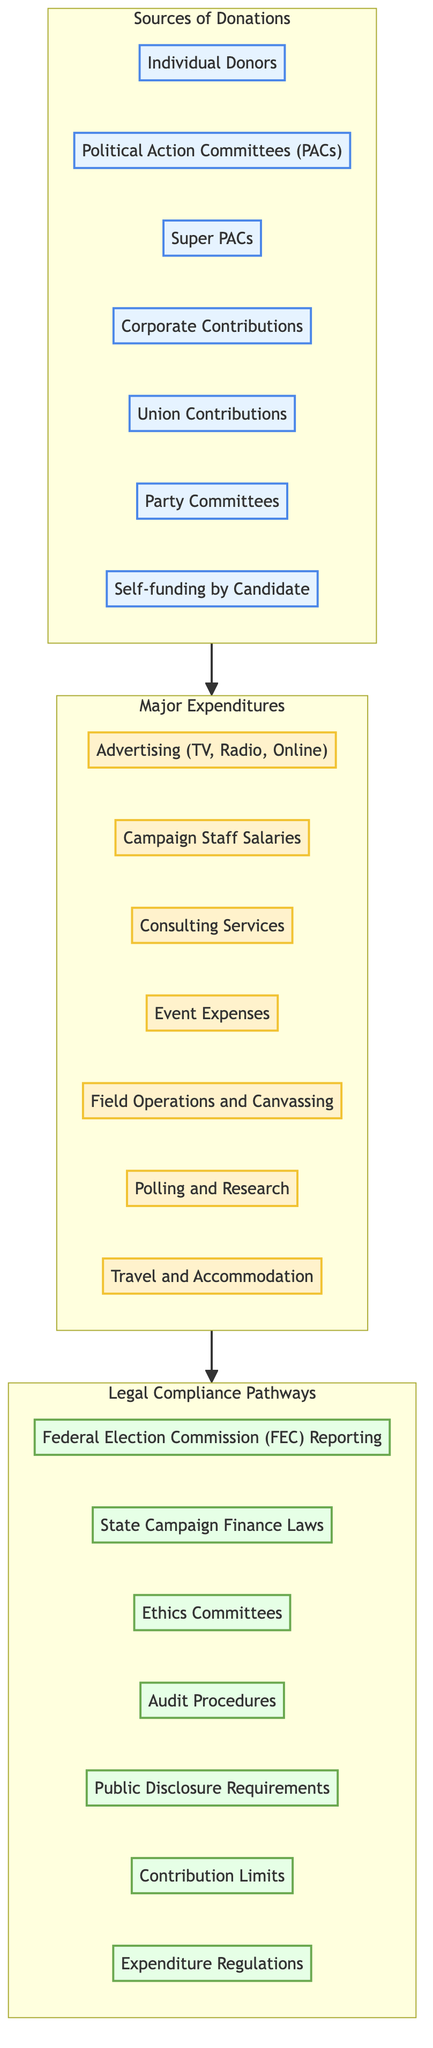What are the sources of donations represented in the diagram? The diagram lists seven sources of donations, which are categorized under "Sources of Donations." These include individual donors, PACs, Super PACs, corporate contributions, union contributions, party committees, and candidate self-funding.
Answer: Individual Donors, Political Action Committees (PACs), Super PACs, Corporate Contributions, Union Contributions, Party Committees, Self-funding by Candidate How many major expenditures are detailed in the diagram? The diagram specifies seven major expenditures under the "Major Expenditures" category. They include various expenses such as advertising, campaign staff salaries, and field operations.
Answer: 7 Which legal compliance pathway is related to expenditure regulations? The diagram outlines a connection between major expenditures and legal compliance pathways. "Expenditure Regulations" is one of the legal compliance items listed, specifically addressing how expenses must adhere to set rules.
Answer: Expenditure Regulations What is the flow direction between the categories? In the diagram, the flow direction indicates that donations lead to expenditures, which then must comply with legal requirements. The arrows illustrate this sequence showing the path from sources to expenditures to compliance.
Answer: From Sources to Expenditures to Compliance Which source of donation is likely to have fewer contribution restrictions? Among the sources listed, individual donors may experience fewer restrictions compared to PACs or Super PACs, which often face stricter regulations regarding contribution limits.
Answer: Individual Donors What is the relationship between advertising and legal compliance pathways? Advertising is categorized under major expenditures, illustrating that funds allocated to advertising must also adhere to legal compliance pathways, such as FEC reporting and expenditure regulations.
Answer: Advertising must comply with FEC Reporting and Expenditure Regulations How many elements fall under legal compliance pathways? The diagram presents seven distinct elements categorized under legal compliance pathways. Each pathway is essential for ensuring proper campaign finance conduct and reporting requirements.
Answer: 7 Which major expenditure category is linked to field operations? The arrow from "Major Expenditures" directly connects field operations and canvassing to the compliance pathways segment, showing that these expenditures must follow legal regulations.
Answer: Field Operations and Canvassing What must candidates do to ensure legal compliance regarding donations? Candidates are required to follow FEC reporting and adhere to state campaign finance laws and public disclosure requirements when managing and reporting donations.
Answer: FEC Reporting, State Campaign Finance Laws 